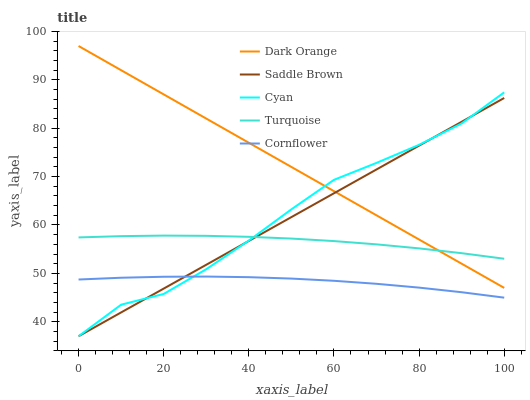Does Cornflower have the minimum area under the curve?
Answer yes or no. Yes. Does Dark Orange have the maximum area under the curve?
Answer yes or no. Yes. Does Turquoise have the minimum area under the curve?
Answer yes or no. No. Does Turquoise have the maximum area under the curve?
Answer yes or no. No. Is Saddle Brown the smoothest?
Answer yes or no. Yes. Is Cyan the roughest?
Answer yes or no. Yes. Is Turquoise the smoothest?
Answer yes or no. No. Is Turquoise the roughest?
Answer yes or no. No. Does Saddle Brown have the lowest value?
Answer yes or no. Yes. Does Cornflower have the lowest value?
Answer yes or no. No. Does Dark Orange have the highest value?
Answer yes or no. Yes. Does Turquoise have the highest value?
Answer yes or no. No. Is Cornflower less than Dark Orange?
Answer yes or no. Yes. Is Dark Orange greater than Cornflower?
Answer yes or no. Yes. Does Cyan intersect Cornflower?
Answer yes or no. Yes. Is Cyan less than Cornflower?
Answer yes or no. No. Is Cyan greater than Cornflower?
Answer yes or no. No. Does Cornflower intersect Dark Orange?
Answer yes or no. No. 